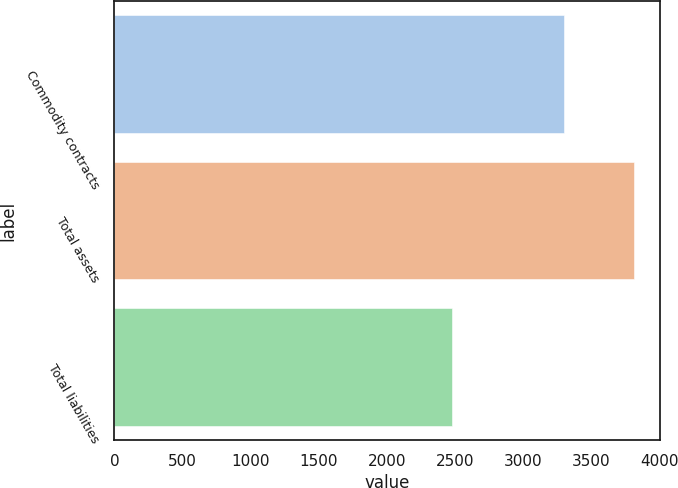Convert chart. <chart><loc_0><loc_0><loc_500><loc_500><bar_chart><fcel>Commodity contracts<fcel>Total assets<fcel>Total liabilities<nl><fcel>3303<fcel>3814<fcel>2481<nl></chart> 